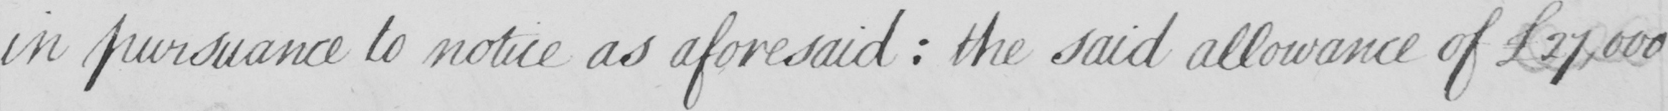What is written in this line of handwriting? in pursuance to notice as aforesaid  :  the said allowance of £27,000 